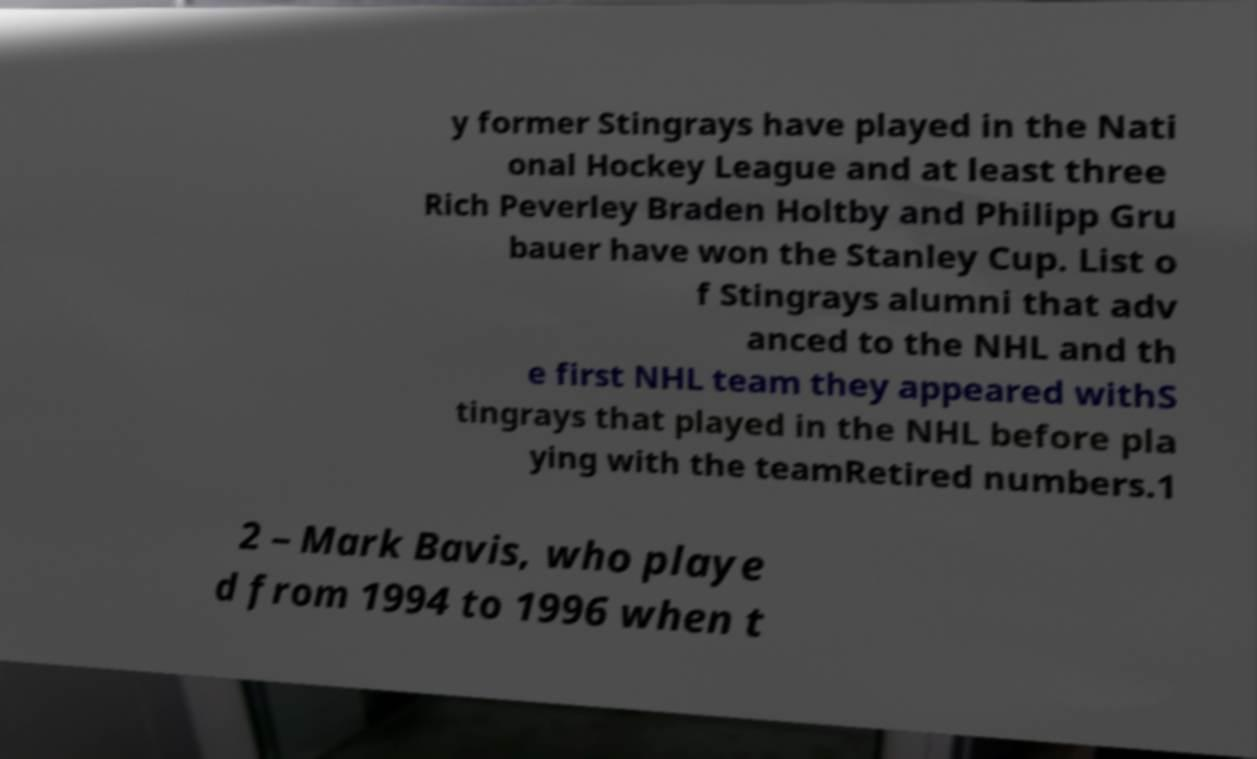For documentation purposes, I need the text within this image transcribed. Could you provide that? y former Stingrays have played in the Nati onal Hockey League and at least three Rich Peverley Braden Holtby and Philipp Gru bauer have won the Stanley Cup. List o f Stingrays alumni that adv anced to the NHL and th e first NHL team they appeared withS tingrays that played in the NHL before pla ying with the teamRetired numbers.1 2 – Mark Bavis, who playe d from 1994 to 1996 when t 